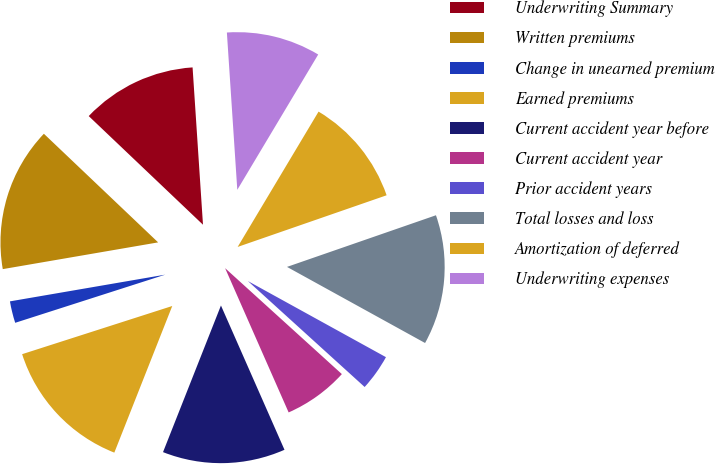<chart> <loc_0><loc_0><loc_500><loc_500><pie_chart><fcel>Underwriting Summary<fcel>Written premiums<fcel>Change in unearned premium<fcel>Earned premiums<fcel>Current accident year before<fcel>Current accident year<fcel>Prior accident years<fcel>Total losses and loss<fcel>Amortization of deferred<fcel>Underwriting expenses<nl><fcel>11.85%<fcel>14.81%<fcel>2.23%<fcel>14.07%<fcel>12.59%<fcel>6.67%<fcel>3.71%<fcel>13.33%<fcel>11.11%<fcel>9.63%<nl></chart> 